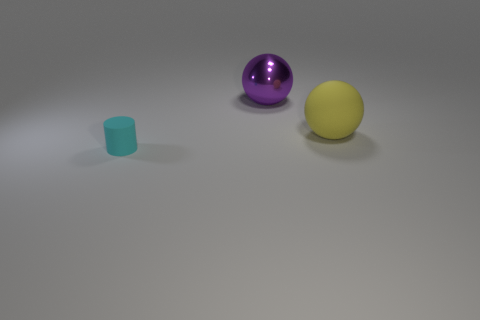Add 3 balls. How many objects exist? 6 Subtract all purple balls. How many balls are left? 1 Subtract 1 cylinders. How many cylinders are left? 0 Add 2 purple metal spheres. How many purple metal spheres are left? 3 Add 3 large yellow things. How many large yellow things exist? 4 Subtract 0 gray cylinders. How many objects are left? 3 Subtract all cylinders. How many objects are left? 2 Subtract all blue cylinders. Subtract all blue balls. How many cylinders are left? 1 Subtract all big yellow things. Subtract all purple metal things. How many objects are left? 1 